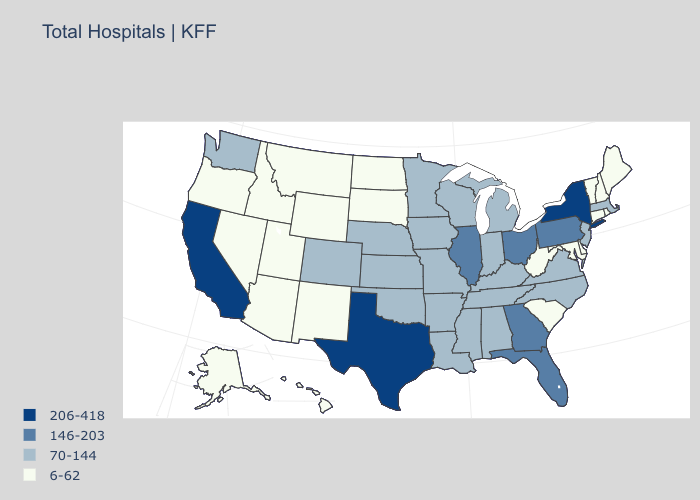Which states have the highest value in the USA?
Write a very short answer. California, New York, Texas. Does the first symbol in the legend represent the smallest category?
Be succinct. No. Does the map have missing data?
Give a very brief answer. No. Name the states that have a value in the range 146-203?
Answer briefly. Florida, Georgia, Illinois, Ohio, Pennsylvania. What is the value of Maryland?
Be succinct. 6-62. Does Tennessee have the lowest value in the USA?
Give a very brief answer. No. Which states have the lowest value in the Northeast?
Quick response, please. Connecticut, Maine, New Hampshire, Rhode Island, Vermont. What is the highest value in the West ?
Write a very short answer. 206-418. What is the lowest value in states that border Virginia?
Give a very brief answer. 6-62. Does California have the highest value in the USA?
Write a very short answer. Yes. What is the value of North Carolina?
Write a very short answer. 70-144. Does New Jersey have the lowest value in the Northeast?
Give a very brief answer. No. What is the value of Wisconsin?
Give a very brief answer. 70-144. Does Connecticut have a higher value than Georgia?
Short answer required. No. 